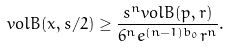<formula> <loc_0><loc_0><loc_500><loc_500>v o l B ( x , s / 2 ) \geq \frac { s ^ { n } v o l B ( p , r ) } { 6 ^ { n } e ^ { ( n - 1 ) b _ { 0 } } r ^ { n } } .</formula> 